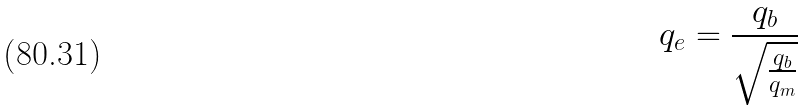Convert formula to latex. <formula><loc_0><loc_0><loc_500><loc_500>q _ { e } = \frac { q _ { b } } { \sqrt { \frac { q _ { b } } { q _ { m } } } }</formula> 